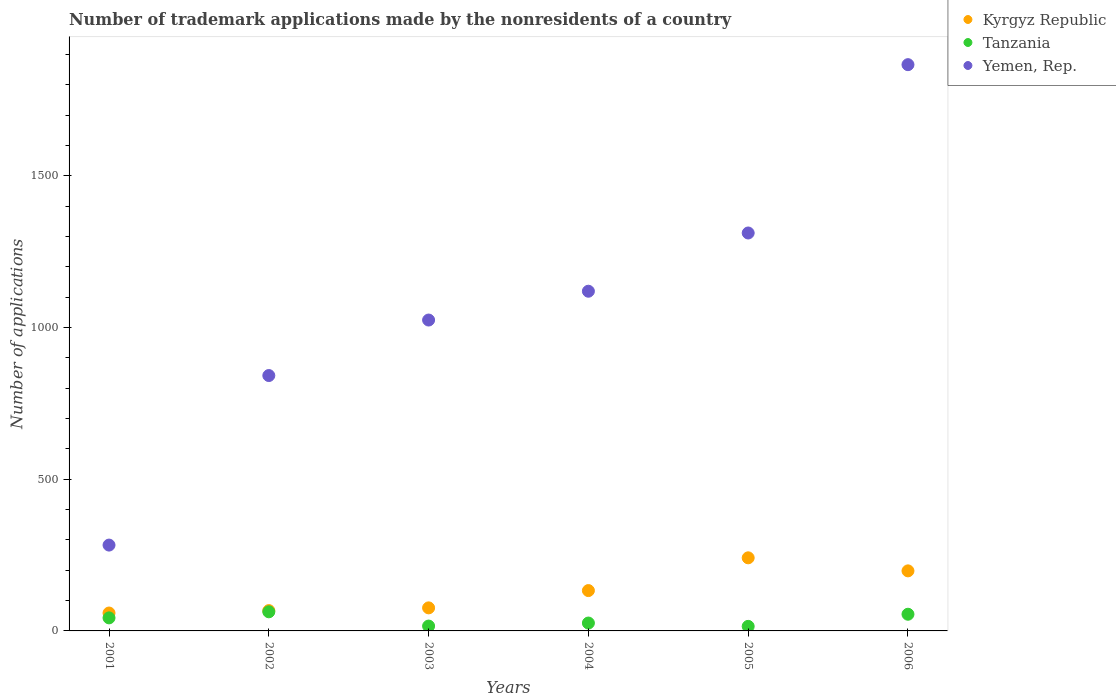How many different coloured dotlines are there?
Give a very brief answer. 3. What is the number of trademark applications made by the nonresidents in Yemen, Rep. in 2006?
Your answer should be compact. 1867. Across all years, what is the maximum number of trademark applications made by the nonresidents in Tanzania?
Provide a short and direct response. 63. Across all years, what is the minimum number of trademark applications made by the nonresidents in Tanzania?
Give a very brief answer. 15. What is the total number of trademark applications made by the nonresidents in Kyrgyz Republic in the graph?
Give a very brief answer. 774. What is the difference between the number of trademark applications made by the nonresidents in Yemen, Rep. in 2002 and that in 2004?
Provide a short and direct response. -278. What is the difference between the number of trademark applications made by the nonresidents in Yemen, Rep. in 2003 and the number of trademark applications made by the nonresidents in Kyrgyz Republic in 2005?
Give a very brief answer. 784. What is the average number of trademark applications made by the nonresidents in Tanzania per year?
Your answer should be compact. 36.33. In the year 2005, what is the difference between the number of trademark applications made by the nonresidents in Kyrgyz Republic and number of trademark applications made by the nonresidents in Yemen, Rep.?
Provide a succinct answer. -1071. In how many years, is the number of trademark applications made by the nonresidents in Yemen, Rep. greater than 1000?
Offer a very short reply. 4. What is the ratio of the number of trademark applications made by the nonresidents in Yemen, Rep. in 2001 to that in 2005?
Offer a terse response. 0.22. Is the difference between the number of trademark applications made by the nonresidents in Kyrgyz Republic in 2001 and 2005 greater than the difference between the number of trademark applications made by the nonresidents in Yemen, Rep. in 2001 and 2005?
Provide a succinct answer. Yes. What is the difference between the highest and the second highest number of trademark applications made by the nonresidents in Yemen, Rep.?
Your response must be concise. 555. What is the difference between the highest and the lowest number of trademark applications made by the nonresidents in Kyrgyz Republic?
Provide a short and direct response. 182. In how many years, is the number of trademark applications made by the nonresidents in Tanzania greater than the average number of trademark applications made by the nonresidents in Tanzania taken over all years?
Provide a short and direct response. 3. Is the sum of the number of trademark applications made by the nonresidents in Tanzania in 2004 and 2005 greater than the maximum number of trademark applications made by the nonresidents in Yemen, Rep. across all years?
Offer a terse response. No. How many years are there in the graph?
Your response must be concise. 6. What is the difference between two consecutive major ticks on the Y-axis?
Provide a short and direct response. 500. How many legend labels are there?
Your answer should be very brief. 3. How are the legend labels stacked?
Keep it short and to the point. Vertical. What is the title of the graph?
Keep it short and to the point. Number of trademark applications made by the nonresidents of a country. Does "Malawi" appear as one of the legend labels in the graph?
Ensure brevity in your answer.  No. What is the label or title of the Y-axis?
Make the answer very short. Number of applications. What is the Number of applications in Kyrgyz Republic in 2001?
Provide a succinct answer. 59. What is the Number of applications of Tanzania in 2001?
Make the answer very short. 43. What is the Number of applications in Yemen, Rep. in 2001?
Ensure brevity in your answer.  283. What is the Number of applications in Kyrgyz Republic in 2002?
Make the answer very short. 67. What is the Number of applications in Yemen, Rep. in 2002?
Provide a short and direct response. 842. What is the Number of applications in Tanzania in 2003?
Provide a succinct answer. 16. What is the Number of applications in Yemen, Rep. in 2003?
Provide a short and direct response. 1025. What is the Number of applications in Kyrgyz Republic in 2004?
Provide a succinct answer. 133. What is the Number of applications in Yemen, Rep. in 2004?
Make the answer very short. 1120. What is the Number of applications in Kyrgyz Republic in 2005?
Your answer should be very brief. 241. What is the Number of applications of Tanzania in 2005?
Your response must be concise. 15. What is the Number of applications in Yemen, Rep. in 2005?
Offer a very short reply. 1312. What is the Number of applications of Kyrgyz Republic in 2006?
Ensure brevity in your answer.  198. What is the Number of applications in Tanzania in 2006?
Offer a terse response. 55. What is the Number of applications of Yemen, Rep. in 2006?
Provide a short and direct response. 1867. Across all years, what is the maximum Number of applications of Kyrgyz Republic?
Make the answer very short. 241. Across all years, what is the maximum Number of applications of Yemen, Rep.?
Keep it short and to the point. 1867. Across all years, what is the minimum Number of applications of Tanzania?
Your answer should be compact. 15. Across all years, what is the minimum Number of applications in Yemen, Rep.?
Provide a short and direct response. 283. What is the total Number of applications in Kyrgyz Republic in the graph?
Offer a very short reply. 774. What is the total Number of applications of Tanzania in the graph?
Your answer should be very brief. 218. What is the total Number of applications in Yemen, Rep. in the graph?
Your response must be concise. 6449. What is the difference between the Number of applications in Yemen, Rep. in 2001 and that in 2002?
Your response must be concise. -559. What is the difference between the Number of applications in Kyrgyz Republic in 2001 and that in 2003?
Offer a terse response. -17. What is the difference between the Number of applications of Yemen, Rep. in 2001 and that in 2003?
Ensure brevity in your answer.  -742. What is the difference between the Number of applications of Kyrgyz Republic in 2001 and that in 2004?
Make the answer very short. -74. What is the difference between the Number of applications of Yemen, Rep. in 2001 and that in 2004?
Offer a terse response. -837. What is the difference between the Number of applications of Kyrgyz Republic in 2001 and that in 2005?
Your answer should be very brief. -182. What is the difference between the Number of applications in Tanzania in 2001 and that in 2005?
Give a very brief answer. 28. What is the difference between the Number of applications in Yemen, Rep. in 2001 and that in 2005?
Make the answer very short. -1029. What is the difference between the Number of applications in Kyrgyz Republic in 2001 and that in 2006?
Your answer should be compact. -139. What is the difference between the Number of applications of Yemen, Rep. in 2001 and that in 2006?
Ensure brevity in your answer.  -1584. What is the difference between the Number of applications in Tanzania in 2002 and that in 2003?
Provide a succinct answer. 47. What is the difference between the Number of applications in Yemen, Rep. in 2002 and that in 2003?
Provide a short and direct response. -183. What is the difference between the Number of applications in Kyrgyz Republic in 2002 and that in 2004?
Your answer should be very brief. -66. What is the difference between the Number of applications in Yemen, Rep. in 2002 and that in 2004?
Give a very brief answer. -278. What is the difference between the Number of applications of Kyrgyz Republic in 2002 and that in 2005?
Your response must be concise. -174. What is the difference between the Number of applications of Tanzania in 2002 and that in 2005?
Your answer should be very brief. 48. What is the difference between the Number of applications in Yemen, Rep. in 2002 and that in 2005?
Provide a succinct answer. -470. What is the difference between the Number of applications of Kyrgyz Republic in 2002 and that in 2006?
Your response must be concise. -131. What is the difference between the Number of applications in Yemen, Rep. in 2002 and that in 2006?
Provide a succinct answer. -1025. What is the difference between the Number of applications in Kyrgyz Republic in 2003 and that in 2004?
Your response must be concise. -57. What is the difference between the Number of applications in Tanzania in 2003 and that in 2004?
Make the answer very short. -10. What is the difference between the Number of applications in Yemen, Rep. in 2003 and that in 2004?
Give a very brief answer. -95. What is the difference between the Number of applications in Kyrgyz Republic in 2003 and that in 2005?
Offer a very short reply. -165. What is the difference between the Number of applications in Tanzania in 2003 and that in 2005?
Give a very brief answer. 1. What is the difference between the Number of applications of Yemen, Rep. in 2003 and that in 2005?
Your answer should be very brief. -287. What is the difference between the Number of applications in Kyrgyz Republic in 2003 and that in 2006?
Give a very brief answer. -122. What is the difference between the Number of applications in Tanzania in 2003 and that in 2006?
Your answer should be compact. -39. What is the difference between the Number of applications of Yemen, Rep. in 2003 and that in 2006?
Your response must be concise. -842. What is the difference between the Number of applications in Kyrgyz Republic in 2004 and that in 2005?
Offer a very short reply. -108. What is the difference between the Number of applications of Yemen, Rep. in 2004 and that in 2005?
Provide a short and direct response. -192. What is the difference between the Number of applications of Kyrgyz Republic in 2004 and that in 2006?
Give a very brief answer. -65. What is the difference between the Number of applications in Yemen, Rep. in 2004 and that in 2006?
Provide a succinct answer. -747. What is the difference between the Number of applications in Kyrgyz Republic in 2005 and that in 2006?
Offer a very short reply. 43. What is the difference between the Number of applications of Yemen, Rep. in 2005 and that in 2006?
Your answer should be very brief. -555. What is the difference between the Number of applications of Kyrgyz Republic in 2001 and the Number of applications of Tanzania in 2002?
Provide a succinct answer. -4. What is the difference between the Number of applications of Kyrgyz Republic in 2001 and the Number of applications of Yemen, Rep. in 2002?
Ensure brevity in your answer.  -783. What is the difference between the Number of applications in Tanzania in 2001 and the Number of applications in Yemen, Rep. in 2002?
Offer a very short reply. -799. What is the difference between the Number of applications of Kyrgyz Republic in 2001 and the Number of applications of Yemen, Rep. in 2003?
Provide a succinct answer. -966. What is the difference between the Number of applications of Tanzania in 2001 and the Number of applications of Yemen, Rep. in 2003?
Provide a short and direct response. -982. What is the difference between the Number of applications of Kyrgyz Republic in 2001 and the Number of applications of Tanzania in 2004?
Your response must be concise. 33. What is the difference between the Number of applications in Kyrgyz Republic in 2001 and the Number of applications in Yemen, Rep. in 2004?
Keep it short and to the point. -1061. What is the difference between the Number of applications of Tanzania in 2001 and the Number of applications of Yemen, Rep. in 2004?
Your answer should be compact. -1077. What is the difference between the Number of applications in Kyrgyz Republic in 2001 and the Number of applications in Tanzania in 2005?
Provide a succinct answer. 44. What is the difference between the Number of applications in Kyrgyz Republic in 2001 and the Number of applications in Yemen, Rep. in 2005?
Offer a very short reply. -1253. What is the difference between the Number of applications of Tanzania in 2001 and the Number of applications of Yemen, Rep. in 2005?
Your response must be concise. -1269. What is the difference between the Number of applications in Kyrgyz Republic in 2001 and the Number of applications in Tanzania in 2006?
Provide a short and direct response. 4. What is the difference between the Number of applications of Kyrgyz Republic in 2001 and the Number of applications of Yemen, Rep. in 2006?
Ensure brevity in your answer.  -1808. What is the difference between the Number of applications of Tanzania in 2001 and the Number of applications of Yemen, Rep. in 2006?
Make the answer very short. -1824. What is the difference between the Number of applications in Kyrgyz Republic in 2002 and the Number of applications in Tanzania in 2003?
Provide a short and direct response. 51. What is the difference between the Number of applications of Kyrgyz Republic in 2002 and the Number of applications of Yemen, Rep. in 2003?
Offer a terse response. -958. What is the difference between the Number of applications in Tanzania in 2002 and the Number of applications in Yemen, Rep. in 2003?
Your answer should be compact. -962. What is the difference between the Number of applications in Kyrgyz Republic in 2002 and the Number of applications in Yemen, Rep. in 2004?
Provide a succinct answer. -1053. What is the difference between the Number of applications of Tanzania in 2002 and the Number of applications of Yemen, Rep. in 2004?
Ensure brevity in your answer.  -1057. What is the difference between the Number of applications in Kyrgyz Republic in 2002 and the Number of applications in Tanzania in 2005?
Ensure brevity in your answer.  52. What is the difference between the Number of applications of Kyrgyz Republic in 2002 and the Number of applications of Yemen, Rep. in 2005?
Your response must be concise. -1245. What is the difference between the Number of applications in Tanzania in 2002 and the Number of applications in Yemen, Rep. in 2005?
Offer a very short reply. -1249. What is the difference between the Number of applications in Kyrgyz Republic in 2002 and the Number of applications in Tanzania in 2006?
Your response must be concise. 12. What is the difference between the Number of applications in Kyrgyz Republic in 2002 and the Number of applications in Yemen, Rep. in 2006?
Your answer should be compact. -1800. What is the difference between the Number of applications of Tanzania in 2002 and the Number of applications of Yemen, Rep. in 2006?
Ensure brevity in your answer.  -1804. What is the difference between the Number of applications in Kyrgyz Republic in 2003 and the Number of applications in Tanzania in 2004?
Offer a very short reply. 50. What is the difference between the Number of applications of Kyrgyz Republic in 2003 and the Number of applications of Yemen, Rep. in 2004?
Keep it short and to the point. -1044. What is the difference between the Number of applications of Tanzania in 2003 and the Number of applications of Yemen, Rep. in 2004?
Offer a very short reply. -1104. What is the difference between the Number of applications in Kyrgyz Republic in 2003 and the Number of applications in Yemen, Rep. in 2005?
Provide a succinct answer. -1236. What is the difference between the Number of applications of Tanzania in 2003 and the Number of applications of Yemen, Rep. in 2005?
Your response must be concise. -1296. What is the difference between the Number of applications of Kyrgyz Republic in 2003 and the Number of applications of Tanzania in 2006?
Offer a terse response. 21. What is the difference between the Number of applications of Kyrgyz Republic in 2003 and the Number of applications of Yemen, Rep. in 2006?
Ensure brevity in your answer.  -1791. What is the difference between the Number of applications of Tanzania in 2003 and the Number of applications of Yemen, Rep. in 2006?
Your response must be concise. -1851. What is the difference between the Number of applications of Kyrgyz Republic in 2004 and the Number of applications of Tanzania in 2005?
Make the answer very short. 118. What is the difference between the Number of applications of Kyrgyz Republic in 2004 and the Number of applications of Yemen, Rep. in 2005?
Your response must be concise. -1179. What is the difference between the Number of applications of Tanzania in 2004 and the Number of applications of Yemen, Rep. in 2005?
Your answer should be compact. -1286. What is the difference between the Number of applications in Kyrgyz Republic in 2004 and the Number of applications in Tanzania in 2006?
Offer a very short reply. 78. What is the difference between the Number of applications of Kyrgyz Republic in 2004 and the Number of applications of Yemen, Rep. in 2006?
Ensure brevity in your answer.  -1734. What is the difference between the Number of applications in Tanzania in 2004 and the Number of applications in Yemen, Rep. in 2006?
Offer a very short reply. -1841. What is the difference between the Number of applications in Kyrgyz Republic in 2005 and the Number of applications in Tanzania in 2006?
Give a very brief answer. 186. What is the difference between the Number of applications of Kyrgyz Republic in 2005 and the Number of applications of Yemen, Rep. in 2006?
Offer a very short reply. -1626. What is the difference between the Number of applications in Tanzania in 2005 and the Number of applications in Yemen, Rep. in 2006?
Your answer should be very brief. -1852. What is the average Number of applications of Kyrgyz Republic per year?
Offer a terse response. 129. What is the average Number of applications of Tanzania per year?
Your answer should be very brief. 36.33. What is the average Number of applications of Yemen, Rep. per year?
Your response must be concise. 1074.83. In the year 2001, what is the difference between the Number of applications of Kyrgyz Republic and Number of applications of Yemen, Rep.?
Your answer should be very brief. -224. In the year 2001, what is the difference between the Number of applications in Tanzania and Number of applications in Yemen, Rep.?
Your response must be concise. -240. In the year 2002, what is the difference between the Number of applications in Kyrgyz Republic and Number of applications in Tanzania?
Provide a short and direct response. 4. In the year 2002, what is the difference between the Number of applications in Kyrgyz Republic and Number of applications in Yemen, Rep.?
Make the answer very short. -775. In the year 2002, what is the difference between the Number of applications in Tanzania and Number of applications in Yemen, Rep.?
Ensure brevity in your answer.  -779. In the year 2003, what is the difference between the Number of applications of Kyrgyz Republic and Number of applications of Tanzania?
Make the answer very short. 60. In the year 2003, what is the difference between the Number of applications of Kyrgyz Republic and Number of applications of Yemen, Rep.?
Your answer should be compact. -949. In the year 2003, what is the difference between the Number of applications in Tanzania and Number of applications in Yemen, Rep.?
Offer a terse response. -1009. In the year 2004, what is the difference between the Number of applications of Kyrgyz Republic and Number of applications of Tanzania?
Provide a succinct answer. 107. In the year 2004, what is the difference between the Number of applications in Kyrgyz Republic and Number of applications in Yemen, Rep.?
Make the answer very short. -987. In the year 2004, what is the difference between the Number of applications of Tanzania and Number of applications of Yemen, Rep.?
Offer a very short reply. -1094. In the year 2005, what is the difference between the Number of applications in Kyrgyz Republic and Number of applications in Tanzania?
Your response must be concise. 226. In the year 2005, what is the difference between the Number of applications of Kyrgyz Republic and Number of applications of Yemen, Rep.?
Keep it short and to the point. -1071. In the year 2005, what is the difference between the Number of applications in Tanzania and Number of applications in Yemen, Rep.?
Make the answer very short. -1297. In the year 2006, what is the difference between the Number of applications in Kyrgyz Republic and Number of applications in Tanzania?
Your answer should be very brief. 143. In the year 2006, what is the difference between the Number of applications of Kyrgyz Republic and Number of applications of Yemen, Rep.?
Ensure brevity in your answer.  -1669. In the year 2006, what is the difference between the Number of applications of Tanzania and Number of applications of Yemen, Rep.?
Your answer should be compact. -1812. What is the ratio of the Number of applications of Kyrgyz Republic in 2001 to that in 2002?
Give a very brief answer. 0.88. What is the ratio of the Number of applications in Tanzania in 2001 to that in 2002?
Your answer should be compact. 0.68. What is the ratio of the Number of applications of Yemen, Rep. in 2001 to that in 2002?
Provide a short and direct response. 0.34. What is the ratio of the Number of applications of Kyrgyz Republic in 2001 to that in 2003?
Offer a terse response. 0.78. What is the ratio of the Number of applications of Tanzania in 2001 to that in 2003?
Make the answer very short. 2.69. What is the ratio of the Number of applications in Yemen, Rep. in 2001 to that in 2003?
Provide a succinct answer. 0.28. What is the ratio of the Number of applications in Kyrgyz Republic in 2001 to that in 2004?
Offer a very short reply. 0.44. What is the ratio of the Number of applications in Tanzania in 2001 to that in 2004?
Ensure brevity in your answer.  1.65. What is the ratio of the Number of applications in Yemen, Rep. in 2001 to that in 2004?
Make the answer very short. 0.25. What is the ratio of the Number of applications in Kyrgyz Republic in 2001 to that in 2005?
Your response must be concise. 0.24. What is the ratio of the Number of applications in Tanzania in 2001 to that in 2005?
Provide a short and direct response. 2.87. What is the ratio of the Number of applications in Yemen, Rep. in 2001 to that in 2005?
Give a very brief answer. 0.22. What is the ratio of the Number of applications in Kyrgyz Republic in 2001 to that in 2006?
Make the answer very short. 0.3. What is the ratio of the Number of applications in Tanzania in 2001 to that in 2006?
Ensure brevity in your answer.  0.78. What is the ratio of the Number of applications in Yemen, Rep. in 2001 to that in 2006?
Provide a short and direct response. 0.15. What is the ratio of the Number of applications in Kyrgyz Republic in 2002 to that in 2003?
Provide a succinct answer. 0.88. What is the ratio of the Number of applications of Tanzania in 2002 to that in 2003?
Provide a succinct answer. 3.94. What is the ratio of the Number of applications of Yemen, Rep. in 2002 to that in 2003?
Give a very brief answer. 0.82. What is the ratio of the Number of applications in Kyrgyz Republic in 2002 to that in 2004?
Your answer should be compact. 0.5. What is the ratio of the Number of applications in Tanzania in 2002 to that in 2004?
Offer a very short reply. 2.42. What is the ratio of the Number of applications in Yemen, Rep. in 2002 to that in 2004?
Make the answer very short. 0.75. What is the ratio of the Number of applications in Kyrgyz Republic in 2002 to that in 2005?
Provide a short and direct response. 0.28. What is the ratio of the Number of applications in Yemen, Rep. in 2002 to that in 2005?
Offer a very short reply. 0.64. What is the ratio of the Number of applications of Kyrgyz Republic in 2002 to that in 2006?
Give a very brief answer. 0.34. What is the ratio of the Number of applications of Tanzania in 2002 to that in 2006?
Offer a terse response. 1.15. What is the ratio of the Number of applications in Yemen, Rep. in 2002 to that in 2006?
Your answer should be compact. 0.45. What is the ratio of the Number of applications in Tanzania in 2003 to that in 2004?
Keep it short and to the point. 0.62. What is the ratio of the Number of applications of Yemen, Rep. in 2003 to that in 2004?
Ensure brevity in your answer.  0.92. What is the ratio of the Number of applications of Kyrgyz Republic in 2003 to that in 2005?
Make the answer very short. 0.32. What is the ratio of the Number of applications of Tanzania in 2003 to that in 2005?
Offer a very short reply. 1.07. What is the ratio of the Number of applications of Yemen, Rep. in 2003 to that in 2005?
Offer a terse response. 0.78. What is the ratio of the Number of applications of Kyrgyz Republic in 2003 to that in 2006?
Your answer should be compact. 0.38. What is the ratio of the Number of applications of Tanzania in 2003 to that in 2006?
Offer a very short reply. 0.29. What is the ratio of the Number of applications in Yemen, Rep. in 2003 to that in 2006?
Your answer should be compact. 0.55. What is the ratio of the Number of applications of Kyrgyz Republic in 2004 to that in 2005?
Provide a succinct answer. 0.55. What is the ratio of the Number of applications in Tanzania in 2004 to that in 2005?
Your response must be concise. 1.73. What is the ratio of the Number of applications of Yemen, Rep. in 2004 to that in 2005?
Give a very brief answer. 0.85. What is the ratio of the Number of applications in Kyrgyz Republic in 2004 to that in 2006?
Offer a terse response. 0.67. What is the ratio of the Number of applications of Tanzania in 2004 to that in 2006?
Give a very brief answer. 0.47. What is the ratio of the Number of applications of Yemen, Rep. in 2004 to that in 2006?
Your response must be concise. 0.6. What is the ratio of the Number of applications of Kyrgyz Republic in 2005 to that in 2006?
Provide a succinct answer. 1.22. What is the ratio of the Number of applications in Tanzania in 2005 to that in 2006?
Your answer should be compact. 0.27. What is the ratio of the Number of applications in Yemen, Rep. in 2005 to that in 2006?
Provide a succinct answer. 0.7. What is the difference between the highest and the second highest Number of applications of Yemen, Rep.?
Provide a short and direct response. 555. What is the difference between the highest and the lowest Number of applications of Kyrgyz Republic?
Offer a terse response. 182. What is the difference between the highest and the lowest Number of applications in Yemen, Rep.?
Offer a terse response. 1584. 